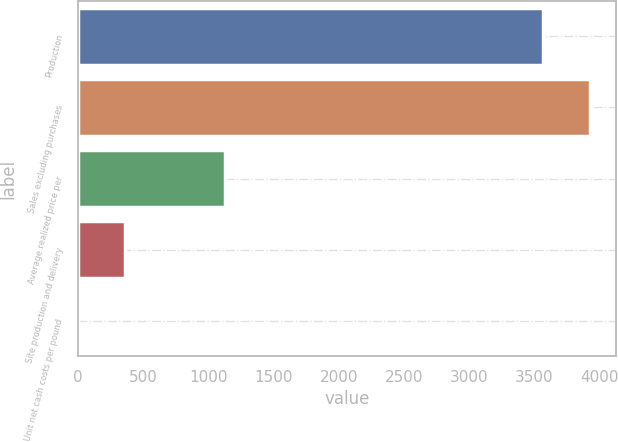Convert chart. <chart><loc_0><loc_0><loc_500><loc_500><bar_chart><fcel>Production<fcel>Sales excluding purchases<fcel>Average realized price per<fcel>Site production and delivery<fcel>Unit net cash costs per pound<nl><fcel>3568<fcel>3928.14<fcel>1129<fcel>361.71<fcel>1.57<nl></chart> 